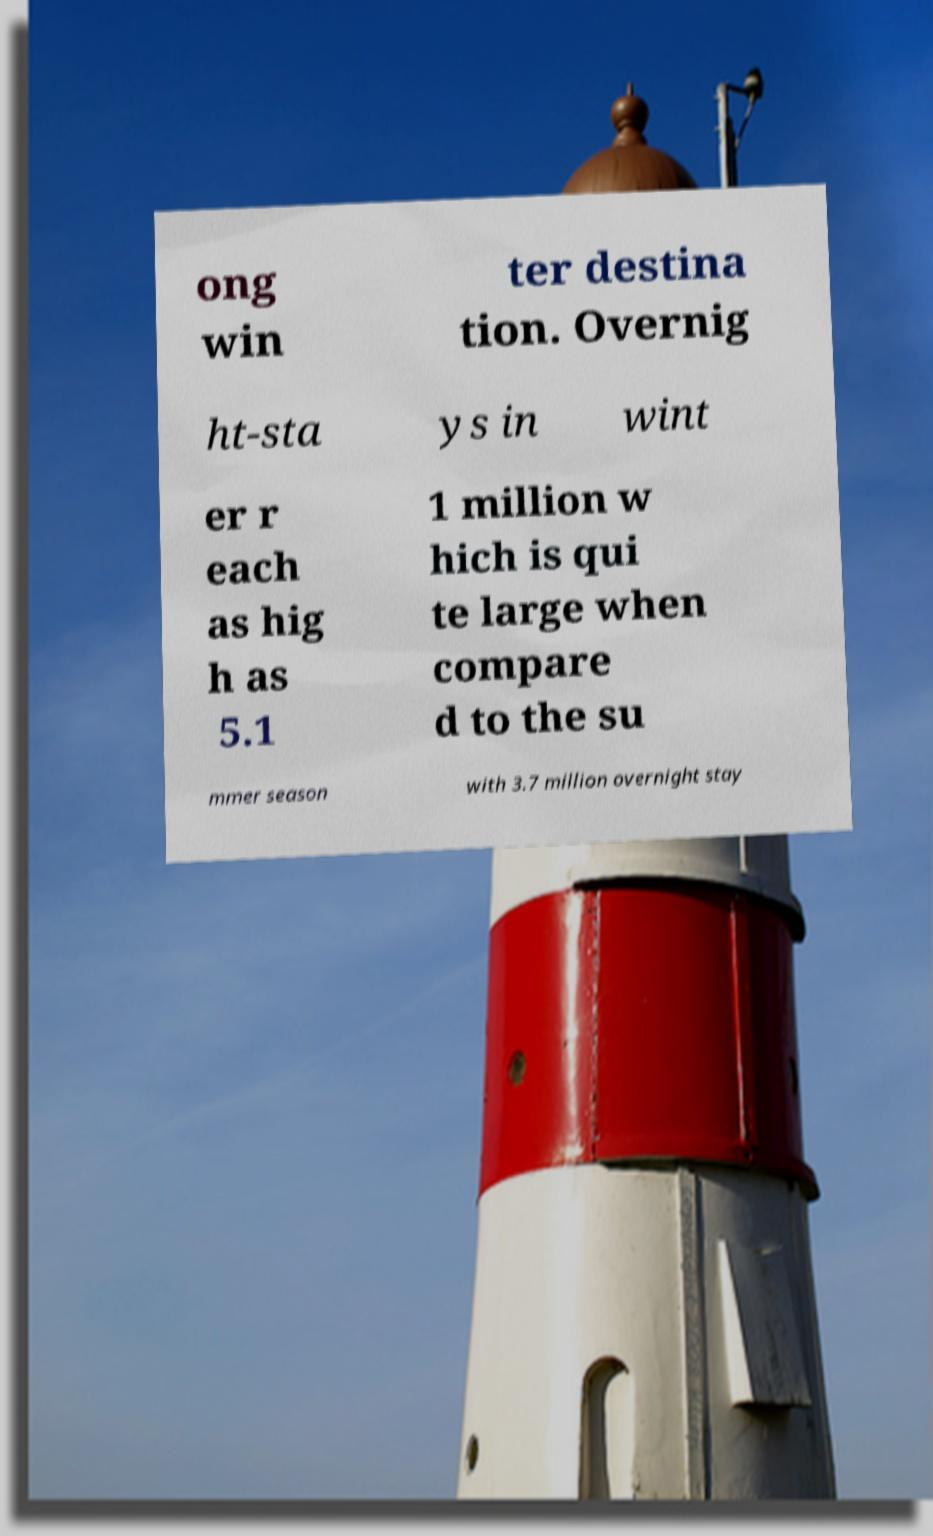What messages or text are displayed in this image? I need them in a readable, typed format. ong win ter destina tion. Overnig ht-sta ys in wint er r each as hig h as 5.1 1 million w hich is qui te large when compare d to the su mmer season with 3.7 million overnight stay 